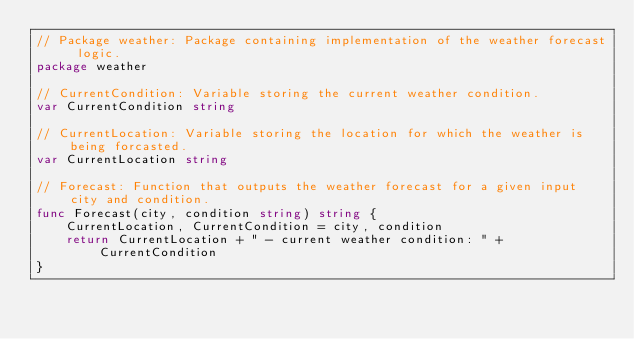Convert code to text. <code><loc_0><loc_0><loc_500><loc_500><_Go_>// Package weather: Package containing implementation of the weather forecast logic.
package weather

// CurrentCondition: Variable storing the current weather condition.
var CurrentCondition string

// CurrentLocation: Variable storing the location for which the weather is being forcasted.
var CurrentLocation string

// Forecast: Function that outputs the weather forecast for a given input city and condition.
func Forecast(city, condition string) string {
	CurrentLocation, CurrentCondition = city, condition
	return CurrentLocation + " - current weather condition: " + CurrentCondition
}
</code> 